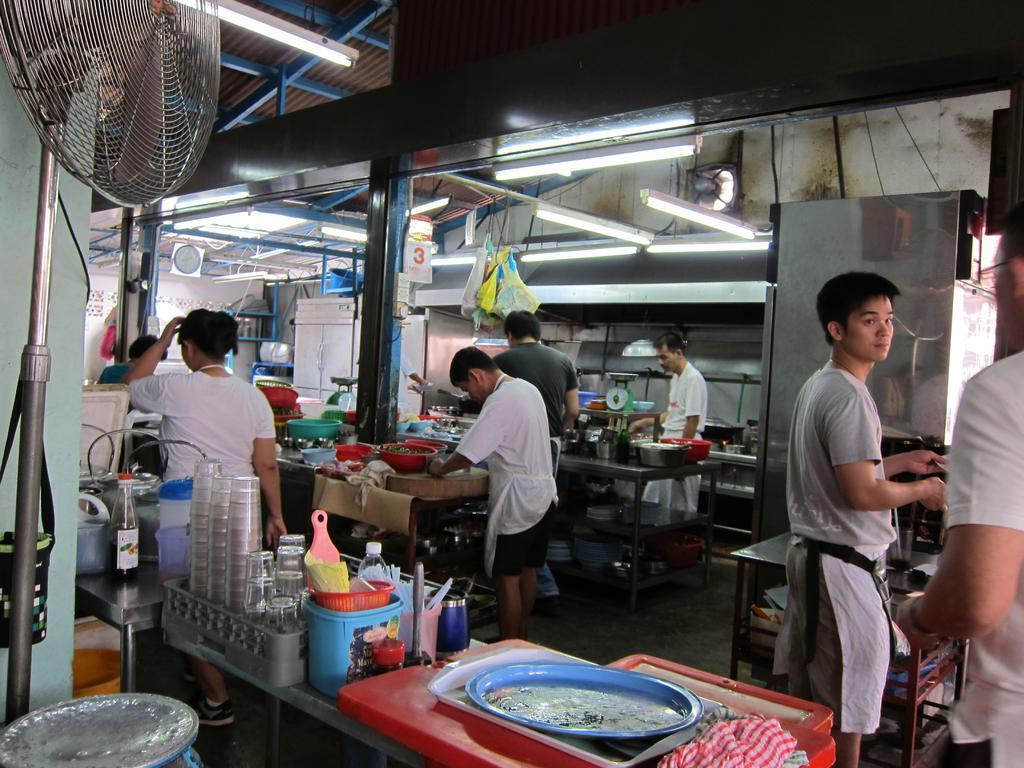Describe this image in one or two sentences. In the picture we can see inside view of the kitchen with few people are standing and preparing the food items and on the tables we can see the trays, glasses, plates and to the ceiling we can see the lights. 